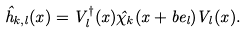Convert formula to latex. <formula><loc_0><loc_0><loc_500><loc_500>\hat { h } _ { k , l } ( x ) = V ^ { \dagger } _ { l } ( x ) \hat { \chi } _ { k } ( x + b e _ { l } ) V _ { l } ( x ) .</formula> 